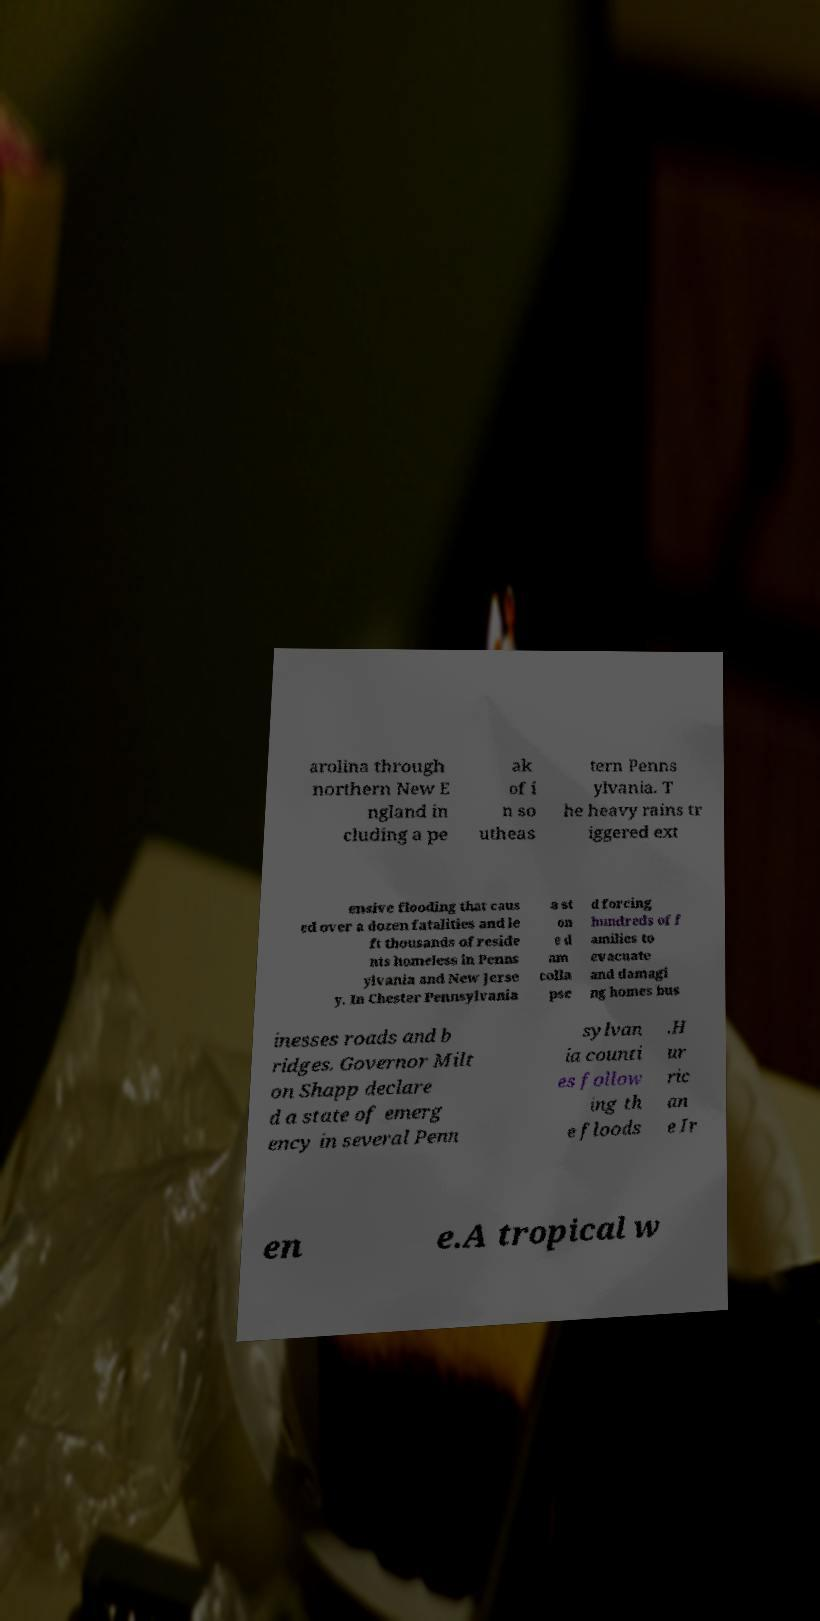Can you accurately transcribe the text from the provided image for me? arolina through northern New E ngland in cluding a pe ak of i n so utheas tern Penns ylvania. T he heavy rains tr iggered ext ensive flooding that caus ed over a dozen fatalities and le ft thousands of reside nts homeless in Penns ylvania and New Jerse y. In Chester Pennsylvania a st on e d am colla pse d forcing hundreds of f amilies to evacuate and damagi ng homes bus inesses roads and b ridges. Governor Milt on Shapp declare d a state of emerg ency in several Penn sylvan ia counti es follow ing th e floods .H ur ric an e Ir en e.A tropical w 